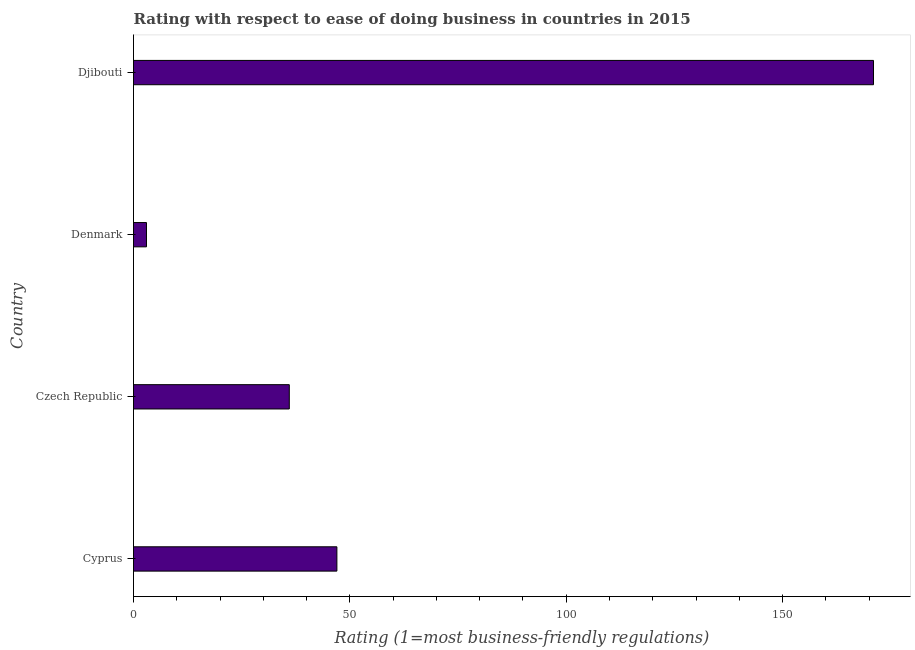What is the title of the graph?
Provide a succinct answer. Rating with respect to ease of doing business in countries in 2015. What is the label or title of the X-axis?
Your response must be concise. Rating (1=most business-friendly regulations). Across all countries, what is the maximum ease of doing business index?
Provide a succinct answer. 171. Across all countries, what is the minimum ease of doing business index?
Provide a short and direct response. 3. In which country was the ease of doing business index maximum?
Your response must be concise. Djibouti. What is the sum of the ease of doing business index?
Ensure brevity in your answer.  257. What is the difference between the ease of doing business index in Cyprus and Czech Republic?
Provide a short and direct response. 11. What is the average ease of doing business index per country?
Provide a short and direct response. 64.25. What is the median ease of doing business index?
Your answer should be very brief. 41.5. In how many countries, is the ease of doing business index greater than 20 ?
Keep it short and to the point. 3. What is the ratio of the ease of doing business index in Denmark to that in Djibouti?
Your answer should be very brief. 0.02. Is the ease of doing business index in Cyprus less than that in Denmark?
Your answer should be very brief. No. What is the difference between the highest and the second highest ease of doing business index?
Ensure brevity in your answer.  124. What is the difference between the highest and the lowest ease of doing business index?
Offer a terse response. 168. In how many countries, is the ease of doing business index greater than the average ease of doing business index taken over all countries?
Ensure brevity in your answer.  1. How many bars are there?
Make the answer very short. 4. Are the values on the major ticks of X-axis written in scientific E-notation?
Provide a short and direct response. No. What is the Rating (1=most business-friendly regulations) of Czech Republic?
Provide a succinct answer. 36. What is the Rating (1=most business-friendly regulations) of Denmark?
Offer a very short reply. 3. What is the Rating (1=most business-friendly regulations) in Djibouti?
Offer a very short reply. 171. What is the difference between the Rating (1=most business-friendly regulations) in Cyprus and Czech Republic?
Provide a short and direct response. 11. What is the difference between the Rating (1=most business-friendly regulations) in Cyprus and Djibouti?
Offer a very short reply. -124. What is the difference between the Rating (1=most business-friendly regulations) in Czech Republic and Djibouti?
Your answer should be compact. -135. What is the difference between the Rating (1=most business-friendly regulations) in Denmark and Djibouti?
Give a very brief answer. -168. What is the ratio of the Rating (1=most business-friendly regulations) in Cyprus to that in Czech Republic?
Your answer should be very brief. 1.31. What is the ratio of the Rating (1=most business-friendly regulations) in Cyprus to that in Denmark?
Your response must be concise. 15.67. What is the ratio of the Rating (1=most business-friendly regulations) in Cyprus to that in Djibouti?
Make the answer very short. 0.28. What is the ratio of the Rating (1=most business-friendly regulations) in Czech Republic to that in Denmark?
Your answer should be very brief. 12. What is the ratio of the Rating (1=most business-friendly regulations) in Czech Republic to that in Djibouti?
Ensure brevity in your answer.  0.21. What is the ratio of the Rating (1=most business-friendly regulations) in Denmark to that in Djibouti?
Offer a very short reply. 0.02. 